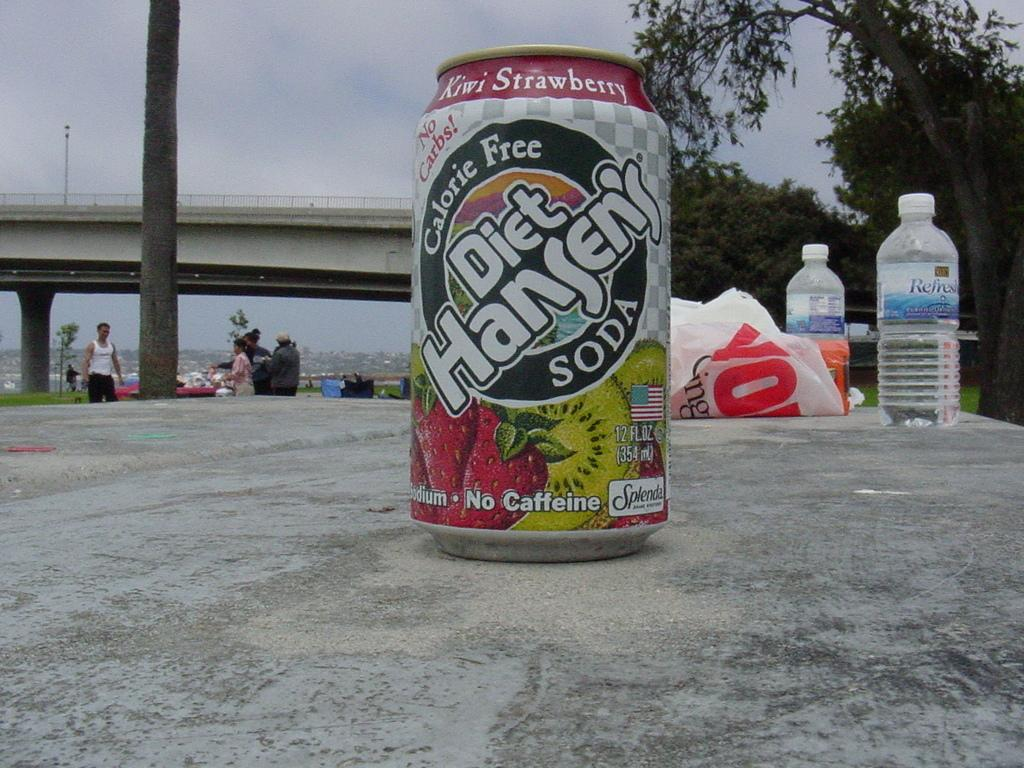<image>
Create a compact narrative representing the image presented. a diet handens soda on a gray surface outside 